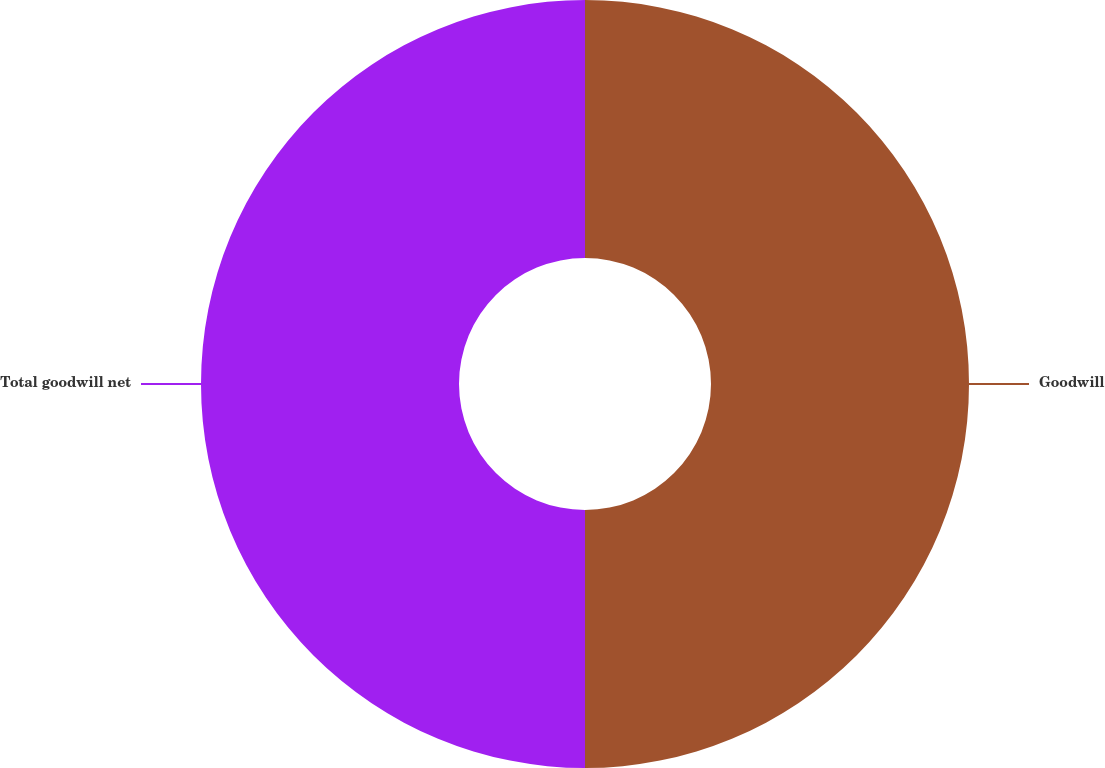Convert chart to OTSL. <chart><loc_0><loc_0><loc_500><loc_500><pie_chart><fcel>Goodwill<fcel>Total goodwill net<nl><fcel>50.0%<fcel>50.0%<nl></chart> 